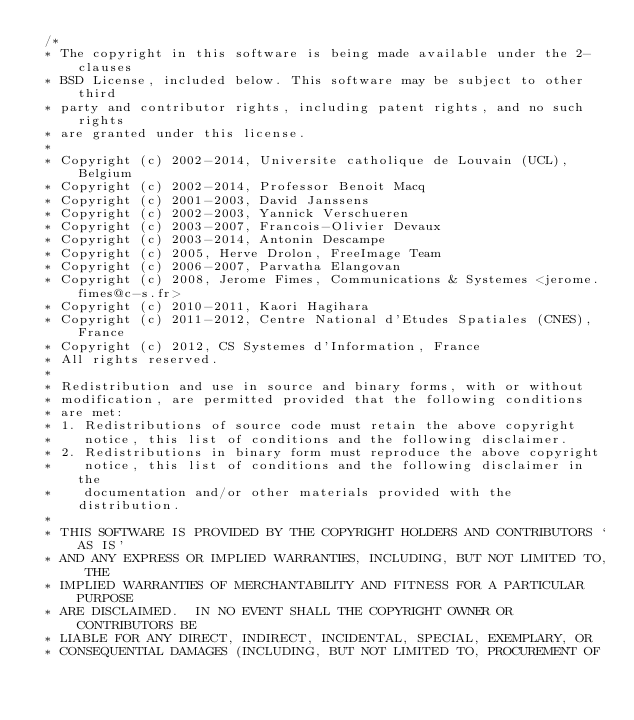<code> <loc_0><loc_0><loc_500><loc_500><_C_> /*
 * The copyright in this software is being made available under the 2-clauses 
 * BSD License, included below. This software may be subject to other third 
 * party and contributor rights, including patent rights, and no such rights
 * are granted under this license.
 *
 * Copyright (c) 2002-2014, Universite catholique de Louvain (UCL), Belgium
 * Copyright (c) 2002-2014, Professor Benoit Macq
 * Copyright (c) 2001-2003, David Janssens
 * Copyright (c) 2002-2003, Yannick Verschueren
 * Copyright (c) 2003-2007, Francois-Olivier Devaux 
 * Copyright (c) 2003-2014, Antonin Descampe
 * Copyright (c) 2005, Herve Drolon, FreeImage Team
 * Copyright (c) 2006-2007, Parvatha Elangovan
 * Copyright (c) 2008, Jerome Fimes, Communications & Systemes <jerome.fimes@c-s.fr>
 * Copyright (c) 2010-2011, Kaori Hagihara
 * Copyright (c) 2011-2012, Centre National d'Etudes Spatiales (CNES), France 
 * Copyright (c) 2012, CS Systemes d'Information, France
 * All rights reserved.
 *
 * Redistribution and use in source and binary forms, with or without
 * modification, are permitted provided that the following conditions
 * are met:
 * 1. Redistributions of source code must retain the above copyright
 *    notice, this list of conditions and the following disclaimer.
 * 2. Redistributions in binary form must reproduce the above copyright
 *    notice, this list of conditions and the following disclaimer in the
 *    documentation and/or other materials provided with the distribution.
 *
 * THIS SOFTWARE IS PROVIDED BY THE COPYRIGHT HOLDERS AND CONTRIBUTORS `AS IS'
 * AND ANY EXPRESS OR IMPLIED WARRANTIES, INCLUDING, BUT NOT LIMITED TO, THE
 * IMPLIED WARRANTIES OF MERCHANTABILITY AND FITNESS FOR A PARTICULAR PURPOSE
 * ARE DISCLAIMED.  IN NO EVENT SHALL THE COPYRIGHT OWNER OR CONTRIBUTORS BE
 * LIABLE FOR ANY DIRECT, INDIRECT, INCIDENTAL, SPECIAL, EXEMPLARY, OR
 * CONSEQUENTIAL DAMAGES (INCLUDING, BUT NOT LIMITED TO, PROCUREMENT OF</code> 